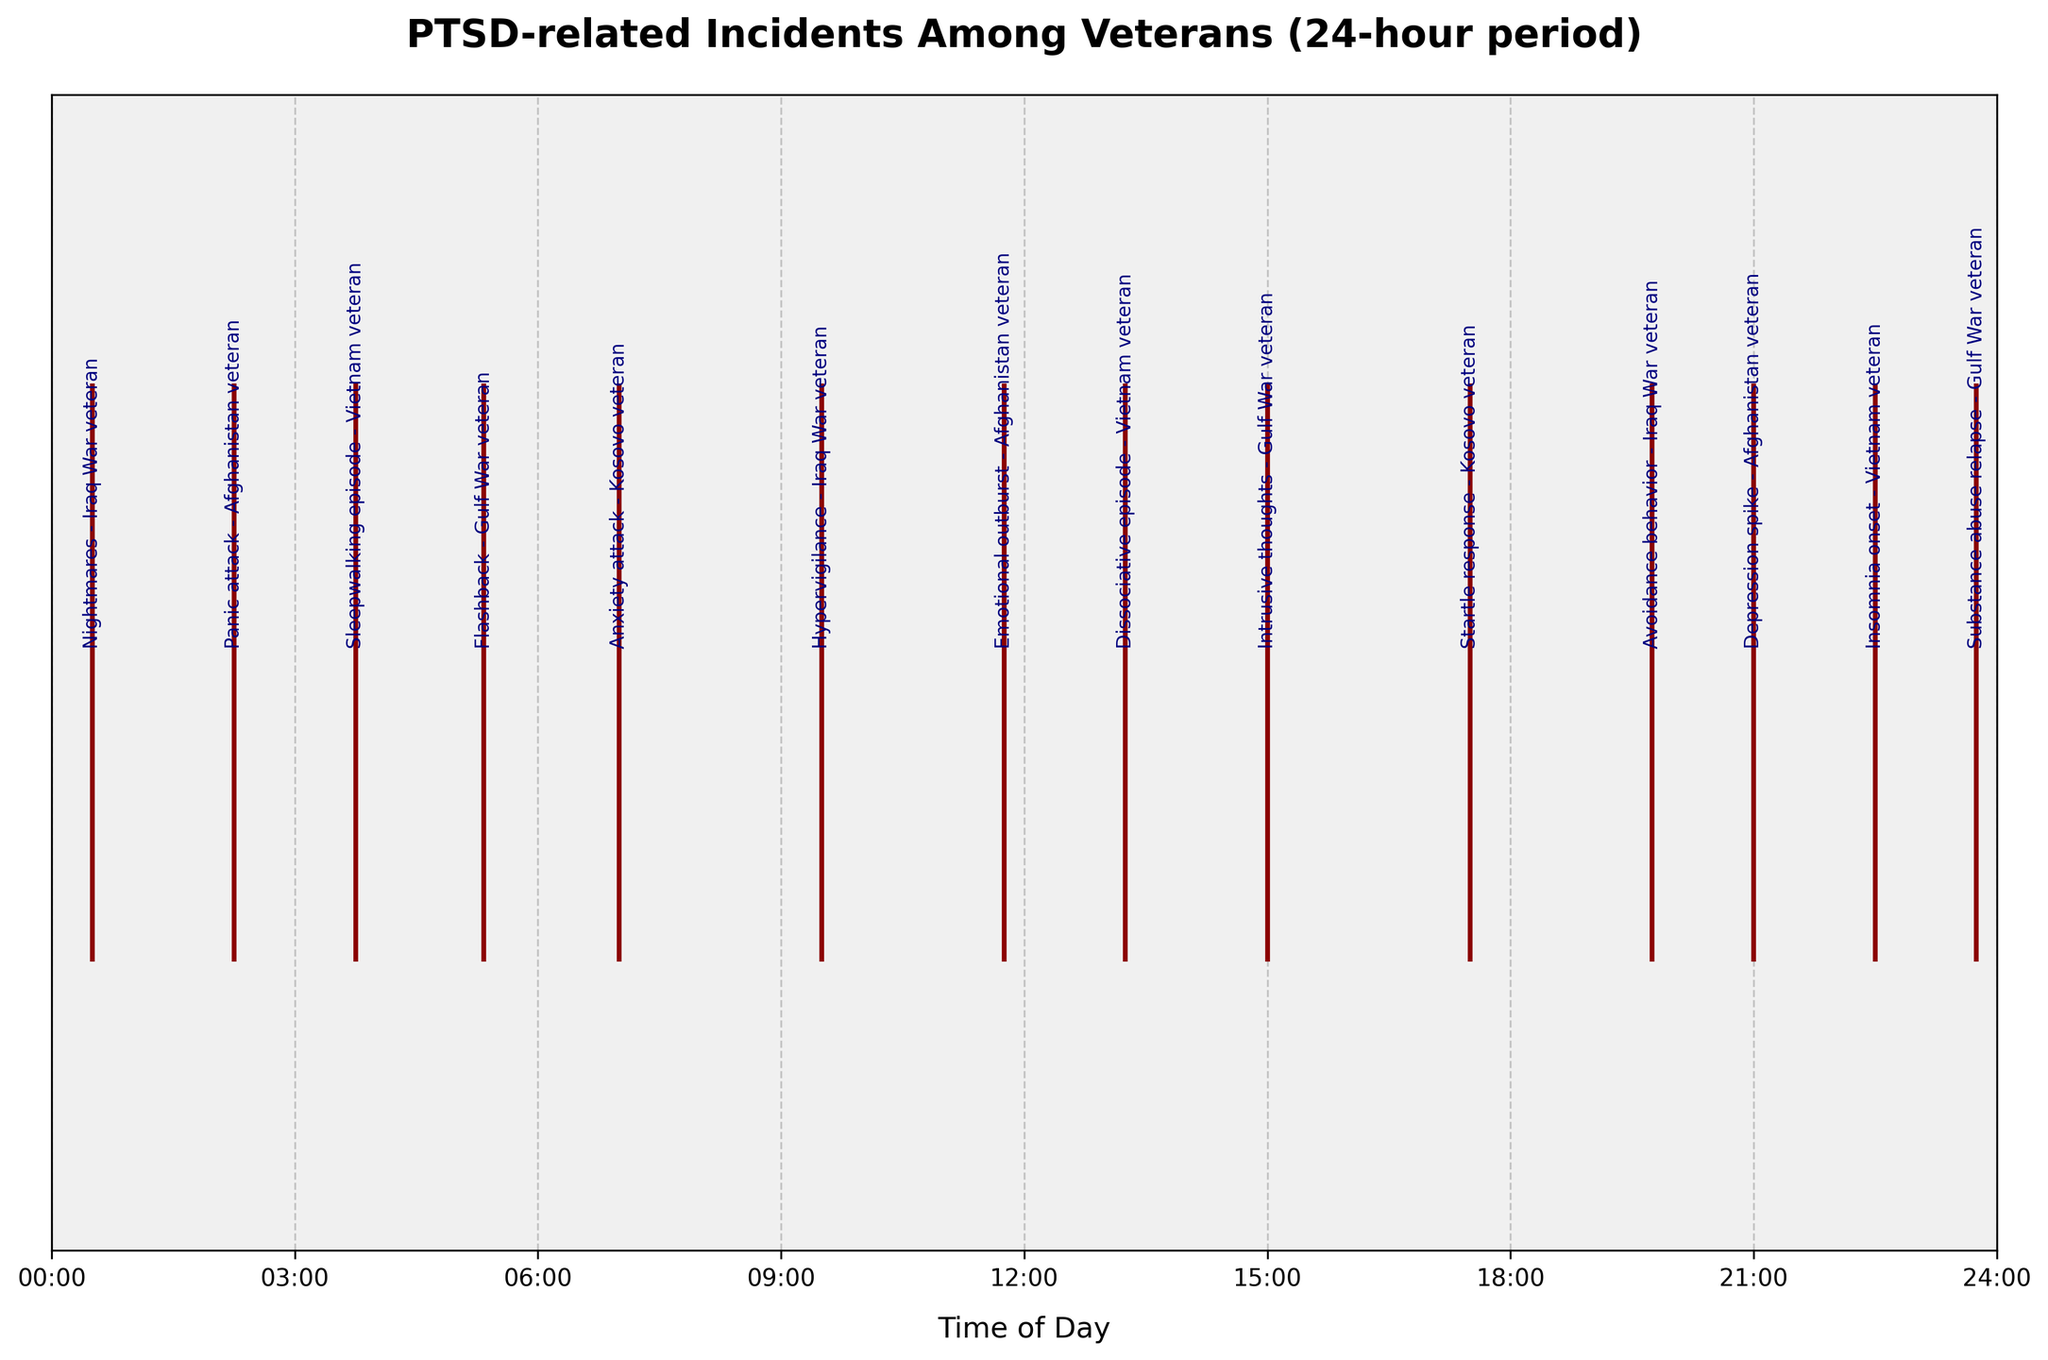What's the title of the figure? The title is usually found at the top of the figure and provides a brief description of what the plot is about. In this case, the title is 'PTSD-related Incidents Among Veterans (24-hour period)'.
Answer: PTSD-related Incidents Among Veterans (24-hour period) How many incidents occurred between 00:00 and 06:00? By looking at the event plot, incidents that occurred between 00:00 and 06:00 are marked along the timeline. Specifically, there are four incidents: 'Nightmares - Iraq War veteran' at 00:30, 'Panic attack - Afghanistan veteran' at 02:15, 'Sleepwalking episode - Vietnam veteran' at 03:45, and 'Flashback - Gulf War veteran' at 05:20.
Answer: 4 Which incident occurred earliest in the day? The earliest incident can be identified by the first mark closest to 00:00 on the timeline. Here, it is the 'Nightmares - Iraq War veteran' incident at 00:30.
Answer: Nightmares - Iraq War veteran How many unique types of incidents are displayed in the figure? By examining the annotations next to each event, we can count the different types of incidents. They include Nightmares, Panic attack, Sleepwalking episode, Flashback, Anxiety attack, Hypervigilance, Emotional outburst, Dissociative episode, Intrusive thoughts, Startle response, Avoidance behavior, Depression spike, Insomnia onset, and Substance abuse relapse, totaling 14 unique types.
Answer: 14 What is the difference in time between the 'Flashback' and 'Hypervigilance' incidents? The 'Flashback - Gulf War veteran' incident occurs at 05:20 and the 'Hypervigilance - Iraq War veteran' incident occurs at 09:30. The time difference is obtained by subtracting 05:20 from 09:30, which is 4 hours and 10 minutes.
Answer: 4 hours and 10 minutes Which veteran group experienced more incidents, Iraq War or Afghanistan? The figure shows 'Nightmares - Iraq War veteran', 'Hypervigilance - Iraq War veteran', and 'Avoidance behavior - Iraq War veteran', totaling three incidents for Iraq War veterans. For Afghanistan veterans, the incidents are 'Panic attack - Afghanistan veteran', 'Emotional outburst - Afghanistan veteran', and 'Depression spike - Afghanistan veteran', also totaling three incidents. Both groups experienced an equal number of incidents.
Answer: Equal (3) How many incidents occurred after 18:00? By observing the timeline and counting the incidents that occur after 18:00, there are four incidents: 'Avoidance behavior - Iraq War veteran' at 19:45, 'Depression spike - Afghanistan veteran' at 21:00, 'Insomnia onset - Vietnam veteran' at 22:30, and 'Substance abuse relapse - Gulf War veteran' at 23:45.
Answer: 4 At what time did the 'Anxiety attack - Kosovo veteran' incident happen? The label corresponding to 'Anxiety attack - Kosovo veteran' is found along the timeline. It happened at 07:00.
Answer: 07:00 